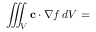<formula> <loc_0><loc_0><loc_500><loc_500>\iiint _ { V } c \cdot \nabla f \, d V =</formula> 